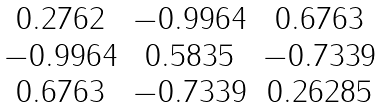<formula> <loc_0><loc_0><loc_500><loc_500>\begin{matrix} 0 . 2 7 6 2 & - 0 . 9 9 6 4 & 0 . 6 7 6 3 \\ - 0 . 9 9 6 4 & 0 . 5 8 3 5 & - 0 . 7 3 3 9 \\ 0 . 6 7 6 3 & - 0 . 7 3 3 9 & 0 . 2 6 2 8 5 \\ \end{matrix}</formula> 